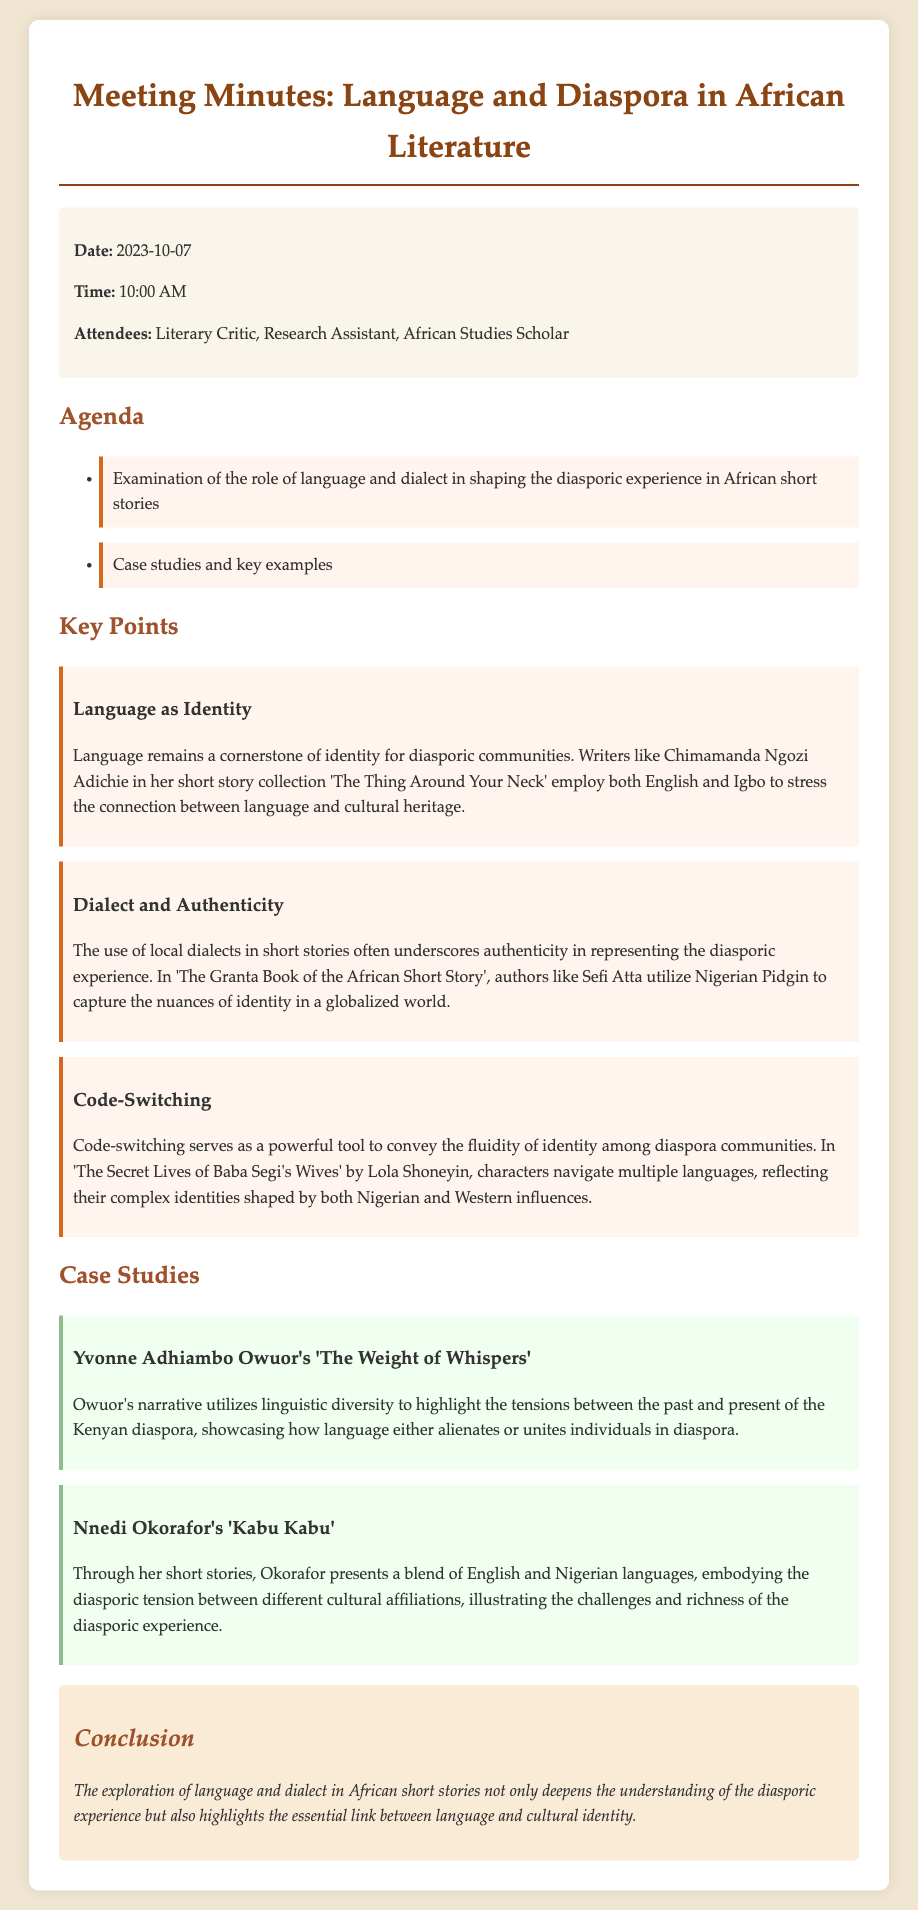What is the meeting date? The meeting date is provided in the meta-info section of the document.
Answer: 2023-10-07 Who is one of the authors discussed regarding language and identity? This information can be found in the key points section discussing language as identity.
Answer: Chimamanda Ngozi Adichie What is a key example of code-switching discussed? This question pertains to one of the key points regarding code-switching found in the document.
Answer: The Secret Lives of Baba Segi's Wives What dialect is referenced in Sefi Atta's work? This information is located in the key points section under dialect and authenticity.
Answer: Nigerian Pidgin Which case study focuses on the Kenyan diaspora? This question requires locating the specific case study mentioned in the document.
Answer: Yvonne Adhiambo Owuor's 'The Weight of Whispers' What is the purpose of the exploration discussed in the conclusion? The conclusion summarizes the insights gained from the examination throughout the document.
Answer: Understanding the diasporic experience How many attendees are mentioned in the meta-info? This information is mentioned in the meta-info section of the document.
Answer: Three What genre do the discussed works belong to? This refers to the general classification of the stories mentioned in the meeting minutes.
Answer: Short stories 